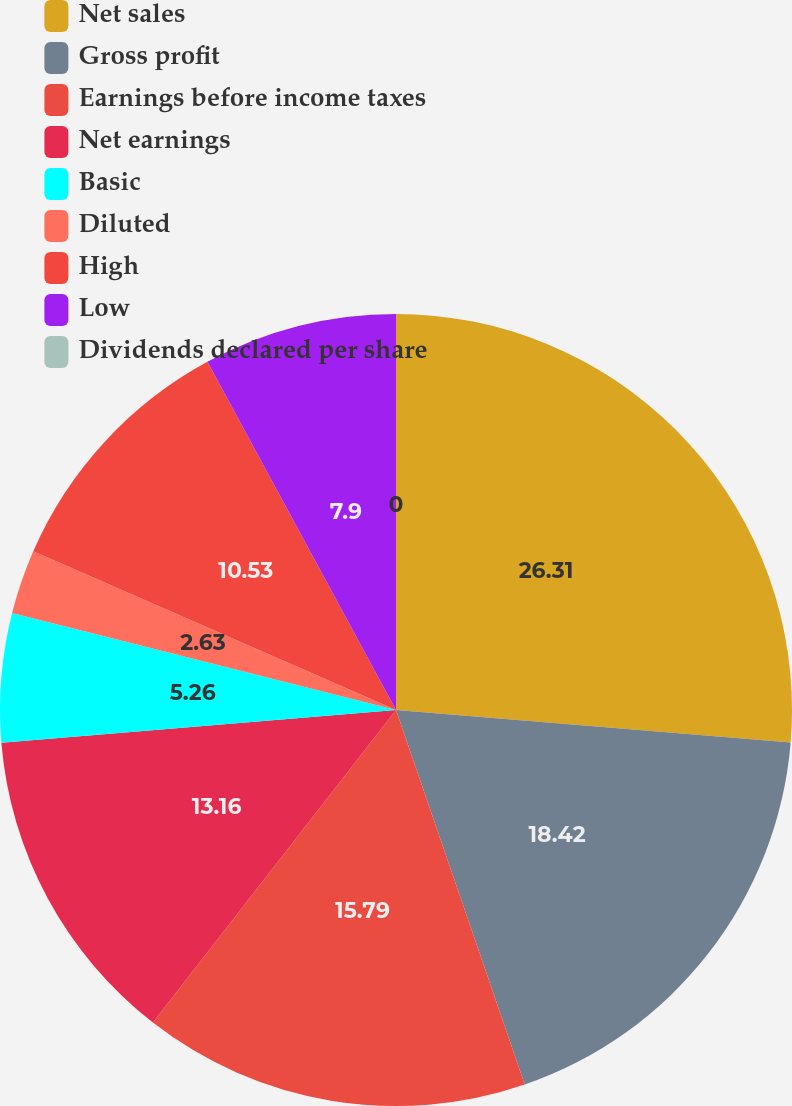Convert chart to OTSL. <chart><loc_0><loc_0><loc_500><loc_500><pie_chart><fcel>Net sales<fcel>Gross profit<fcel>Earnings before income taxes<fcel>Net earnings<fcel>Basic<fcel>Diluted<fcel>High<fcel>Low<fcel>Dividends declared per share<nl><fcel>26.31%<fcel>18.42%<fcel>15.79%<fcel>13.16%<fcel>5.26%<fcel>2.63%<fcel>10.53%<fcel>7.9%<fcel>0.0%<nl></chart> 